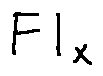<formula> <loc_0><loc_0><loc_500><loc_500>F l _ { X }</formula> 